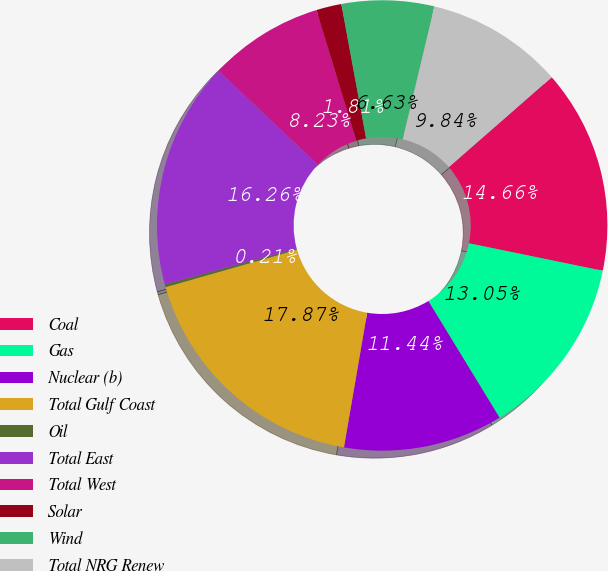Convert chart to OTSL. <chart><loc_0><loc_0><loc_500><loc_500><pie_chart><fcel>Coal<fcel>Gas<fcel>Nuclear (b)<fcel>Total Gulf Coast<fcel>Oil<fcel>Total East<fcel>Total West<fcel>Solar<fcel>Wind<fcel>Total NRG Renew<nl><fcel>14.66%<fcel>13.05%<fcel>11.44%<fcel>17.87%<fcel>0.21%<fcel>16.26%<fcel>8.23%<fcel>1.81%<fcel>6.63%<fcel>9.84%<nl></chart> 